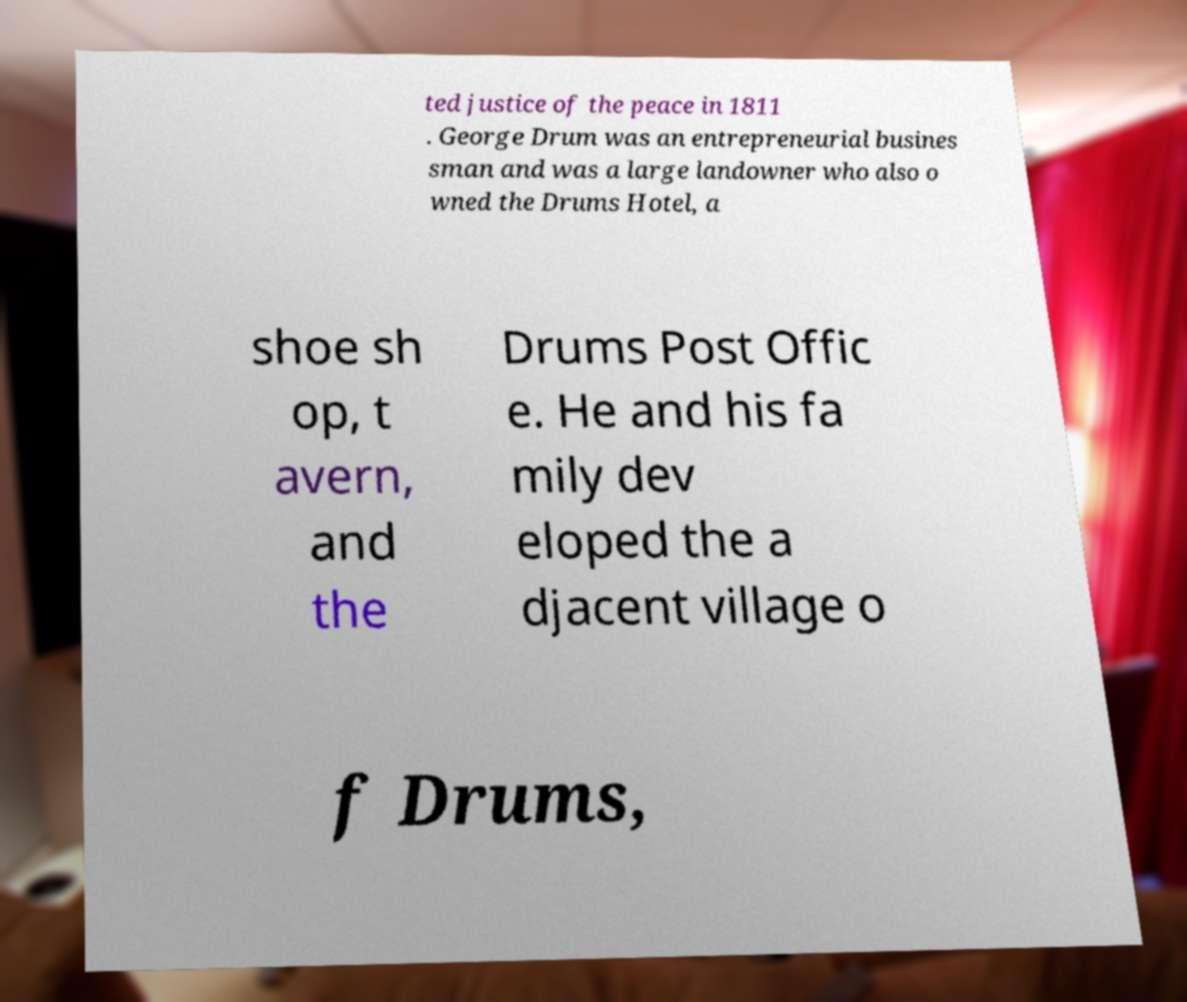Please read and relay the text visible in this image. What does it say? ted justice of the peace in 1811 . George Drum was an entrepreneurial busines sman and was a large landowner who also o wned the Drums Hotel, a shoe sh op, t avern, and the Drums Post Offic e. He and his fa mily dev eloped the a djacent village o f Drums, 